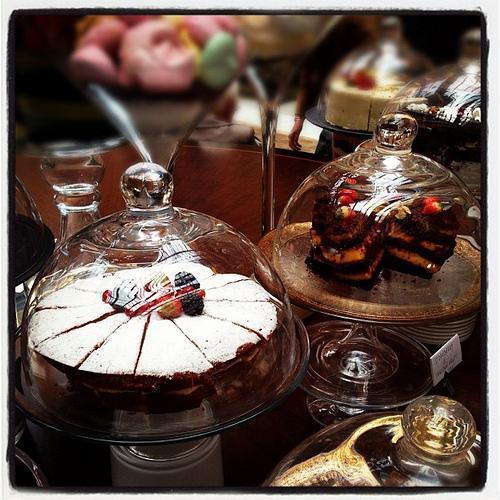How many cakes are in this picture?
Give a very brief answer. 2. How many slices is the cake on the left cut into?
Give a very brief answer. 12. 